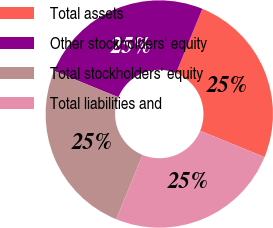<chart> <loc_0><loc_0><loc_500><loc_500><pie_chart><fcel>Total assets<fcel>Other stockholders' equity<fcel>Total stockholders' equity<fcel>Total liabilities and<nl><fcel>25.0%<fcel>25.0%<fcel>25.0%<fcel>25.0%<nl></chart> 